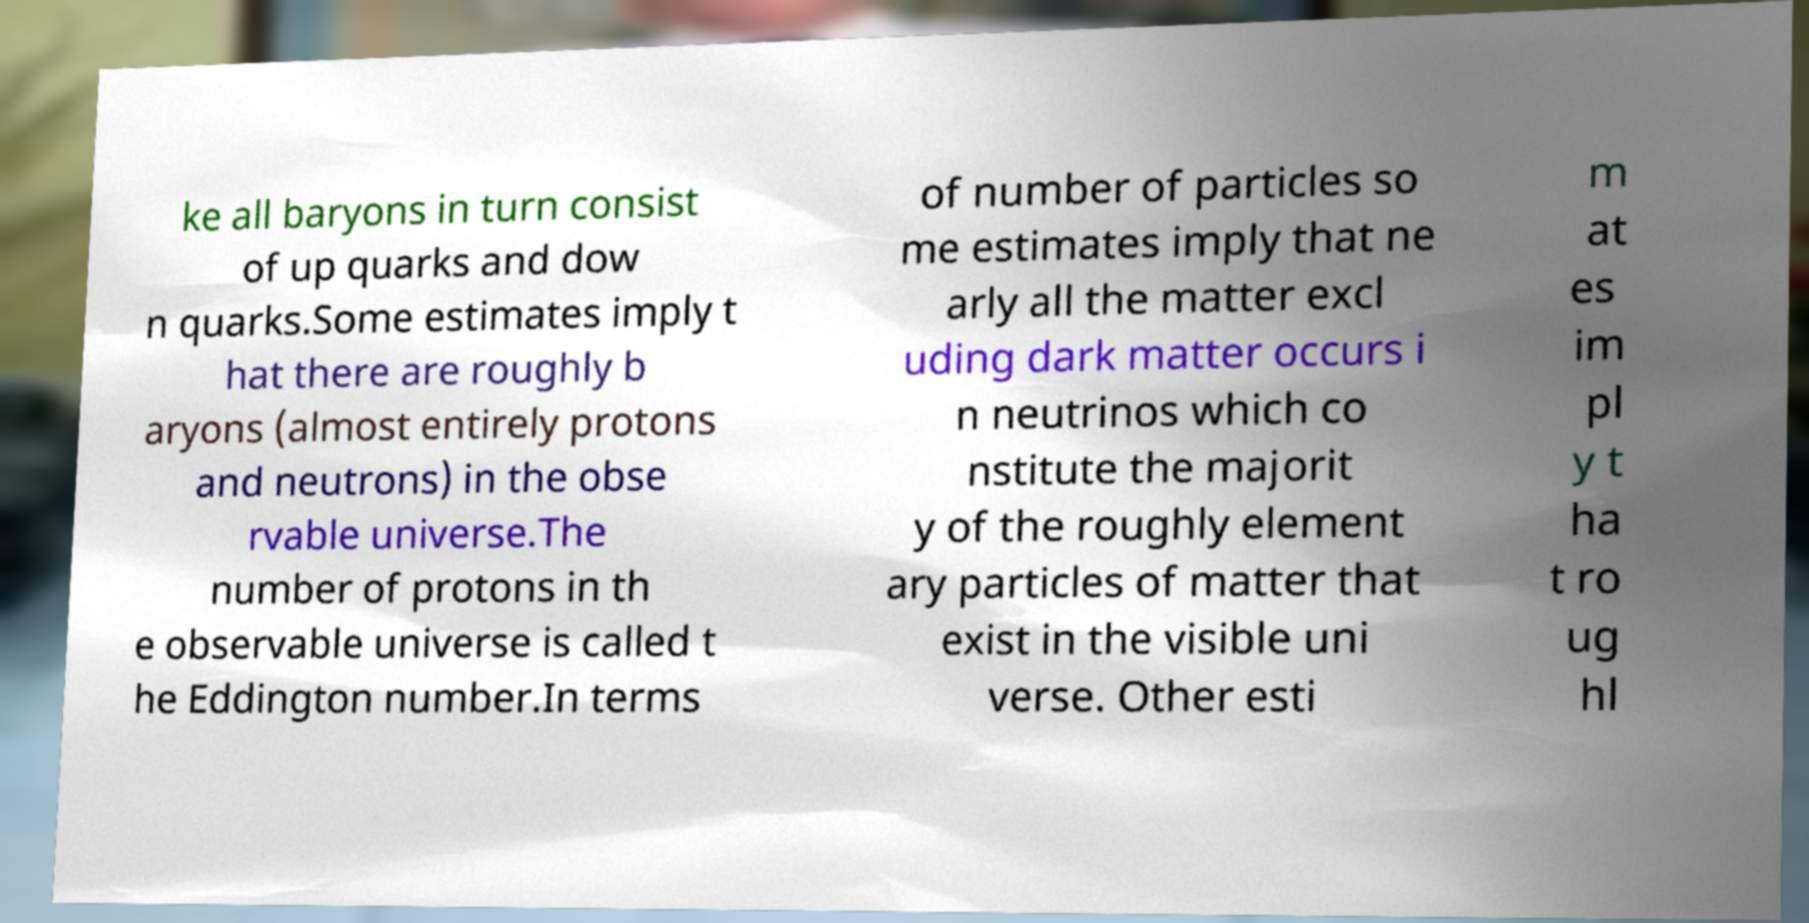I need the written content from this picture converted into text. Can you do that? ke all baryons in turn consist of up quarks and dow n quarks.Some estimates imply t hat there are roughly b aryons (almost entirely protons and neutrons) in the obse rvable universe.The number of protons in th e observable universe is called t he Eddington number.In terms of number of particles so me estimates imply that ne arly all the matter excl uding dark matter occurs i n neutrinos which co nstitute the majorit y of the roughly element ary particles of matter that exist in the visible uni verse. Other esti m at es im pl y t ha t ro ug hl 